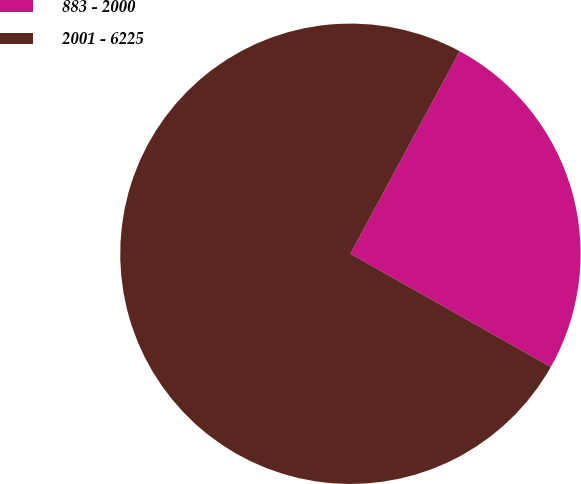Convert chart. <chart><loc_0><loc_0><loc_500><loc_500><pie_chart><fcel>883 - 2000<fcel>2001 - 6225<nl><fcel>25.31%<fcel>74.69%<nl></chart> 